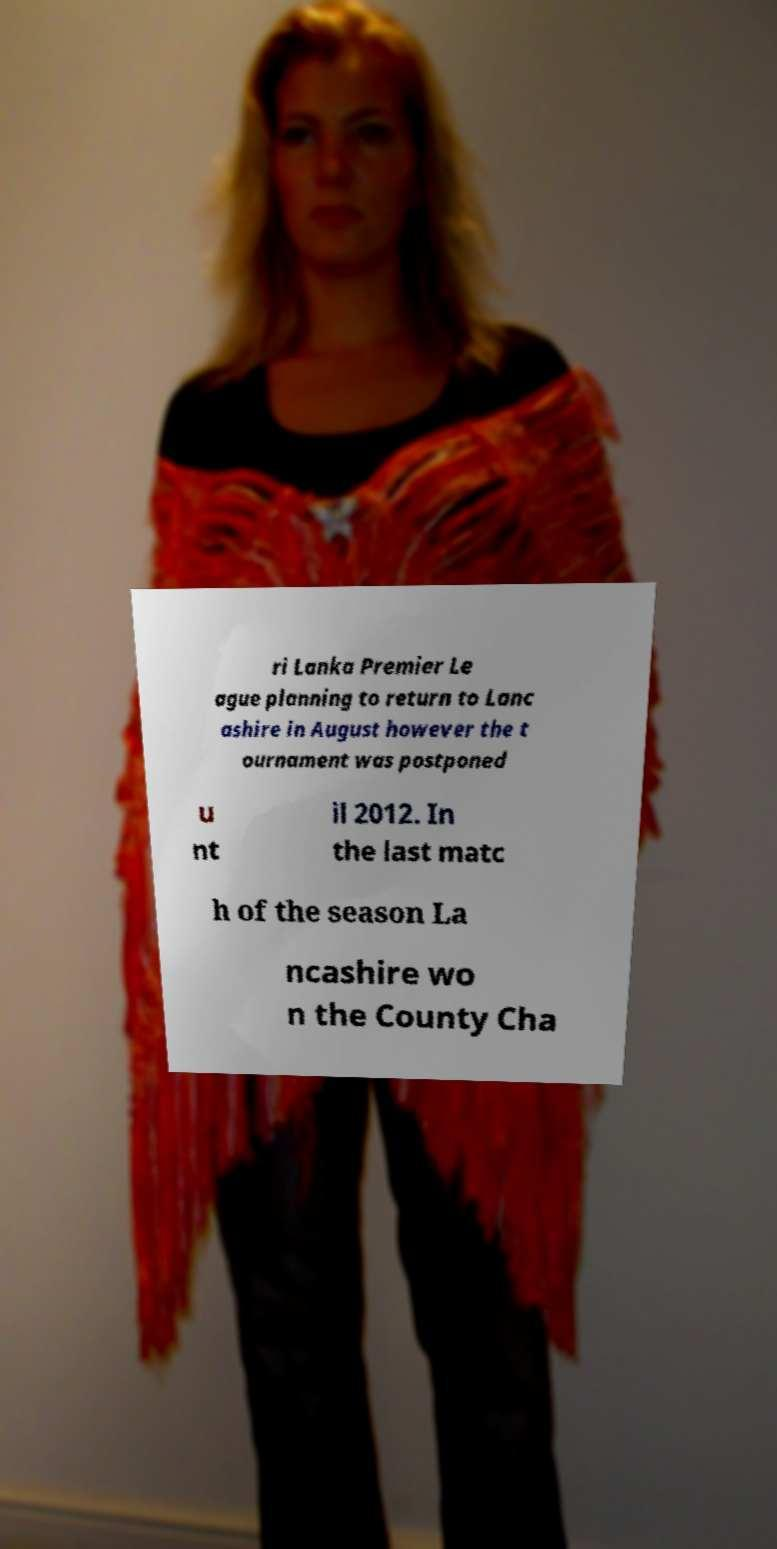Can you accurately transcribe the text from the provided image for me? ri Lanka Premier Le ague planning to return to Lanc ashire in August however the t ournament was postponed u nt il 2012. In the last matc h of the season La ncashire wo n the County Cha 